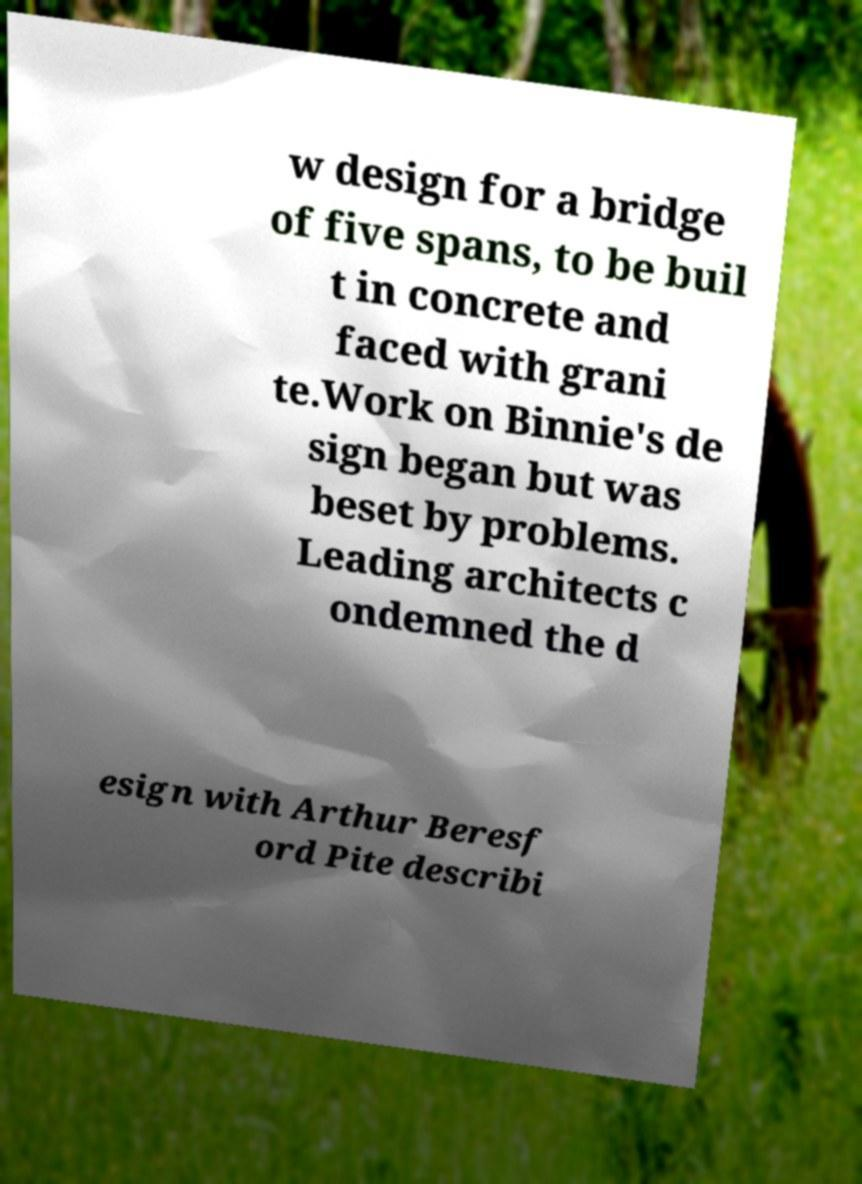Please read and relay the text visible in this image. What does it say? w design for a bridge of five spans, to be buil t in concrete and faced with grani te.Work on Binnie's de sign began but was beset by problems. Leading architects c ondemned the d esign with Arthur Beresf ord Pite describi 